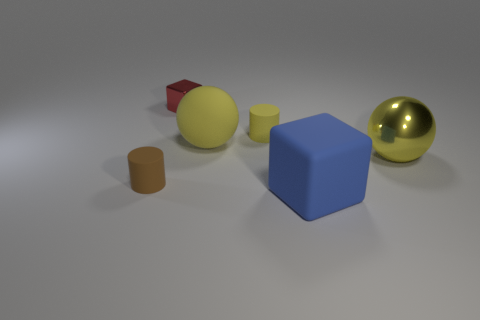How many cyan things are either small metal cubes or large matte cylinders?
Offer a very short reply. 0. What number of things are either large cyan shiny things or things that are behind the small yellow thing?
Give a very brief answer. 1. There is a large yellow ball left of the yellow cylinder; what material is it?
Make the answer very short. Rubber. There is another matte object that is the same size as the blue thing; what is its shape?
Offer a very short reply. Sphere. Are there any small things that have the same shape as the big yellow shiny thing?
Provide a succinct answer. No. Is the material of the red block the same as the small cylinder that is behind the brown matte cylinder?
Provide a succinct answer. No. There is a cylinder that is behind the cylinder that is to the left of the red block; what is its material?
Ensure brevity in your answer.  Rubber. Are there more big matte spheres that are behind the tiny yellow cylinder than yellow cylinders?
Offer a terse response. No. Are there any small objects?
Ensure brevity in your answer.  Yes. There is a cylinder that is behind the yellow metal thing; what color is it?
Give a very brief answer. Yellow. 